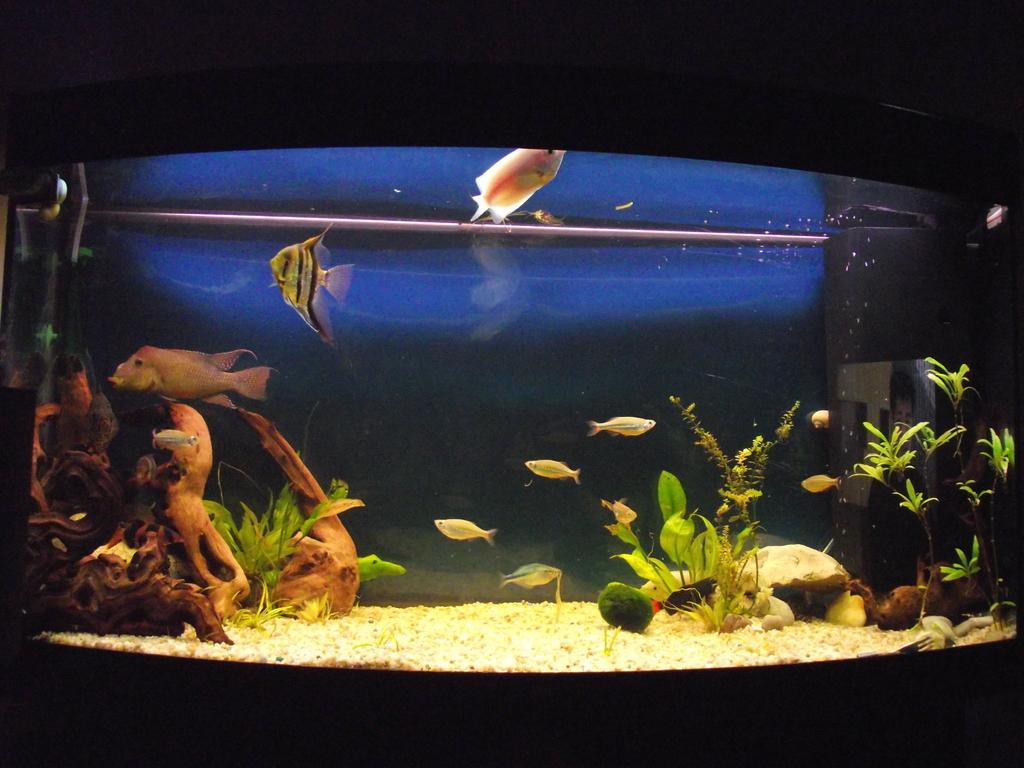What is the main subject of the image? There is an aquarium in the image. How is the aquarium described? The aquarium is described as beautiful. What can be observed about the background of the aquarium? The background of the aquarium is dark. Are there any visible minute details on the glass of the aquarium in the image? There is no mention of minute details on the glass of the aquarium in the provided facts, so it cannot be determined from the image. 